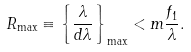Convert formula to latex. <formula><loc_0><loc_0><loc_500><loc_500>R _ { \max } \equiv \left \{ \frac { \lambda } { d \lambda } \right \} _ { \max } < m \frac { f _ { 1 } } { \lambda } .</formula> 